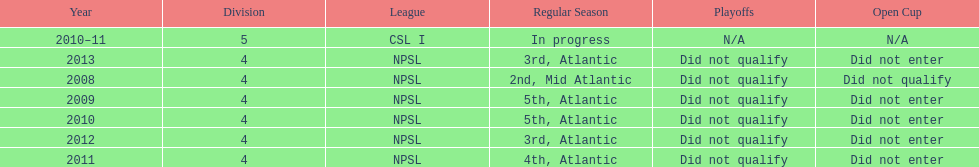How many years did they not qualify for the playoffs? 6. 